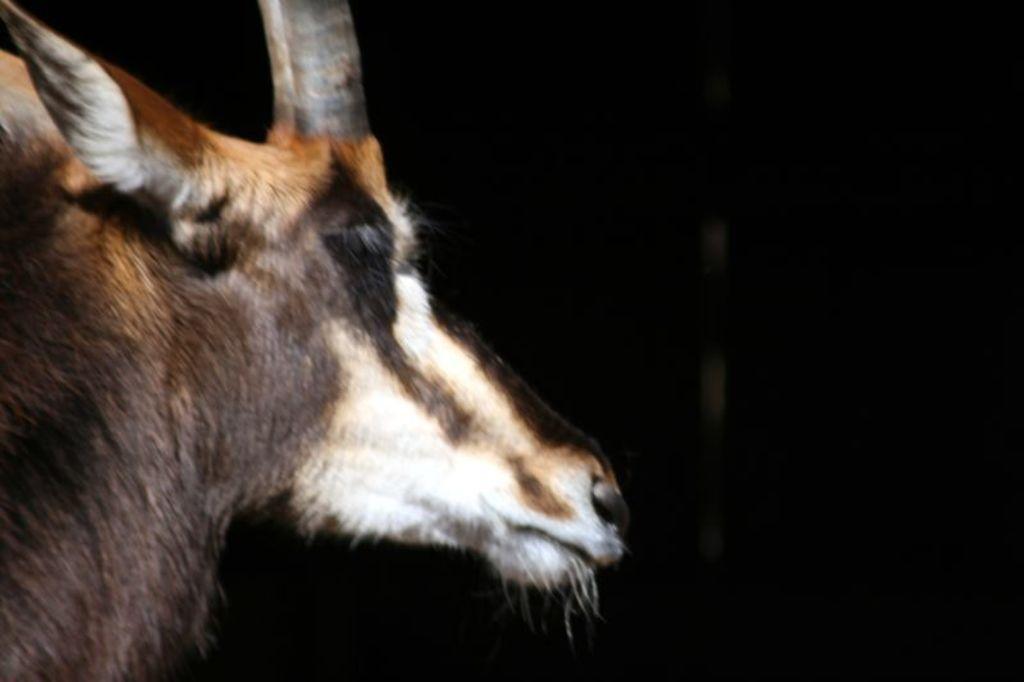In one or two sentences, can you explain what this image depicts? In this picture we can observe an animal which is in brown and white color. There is a horn. In the background it is completely dark. 